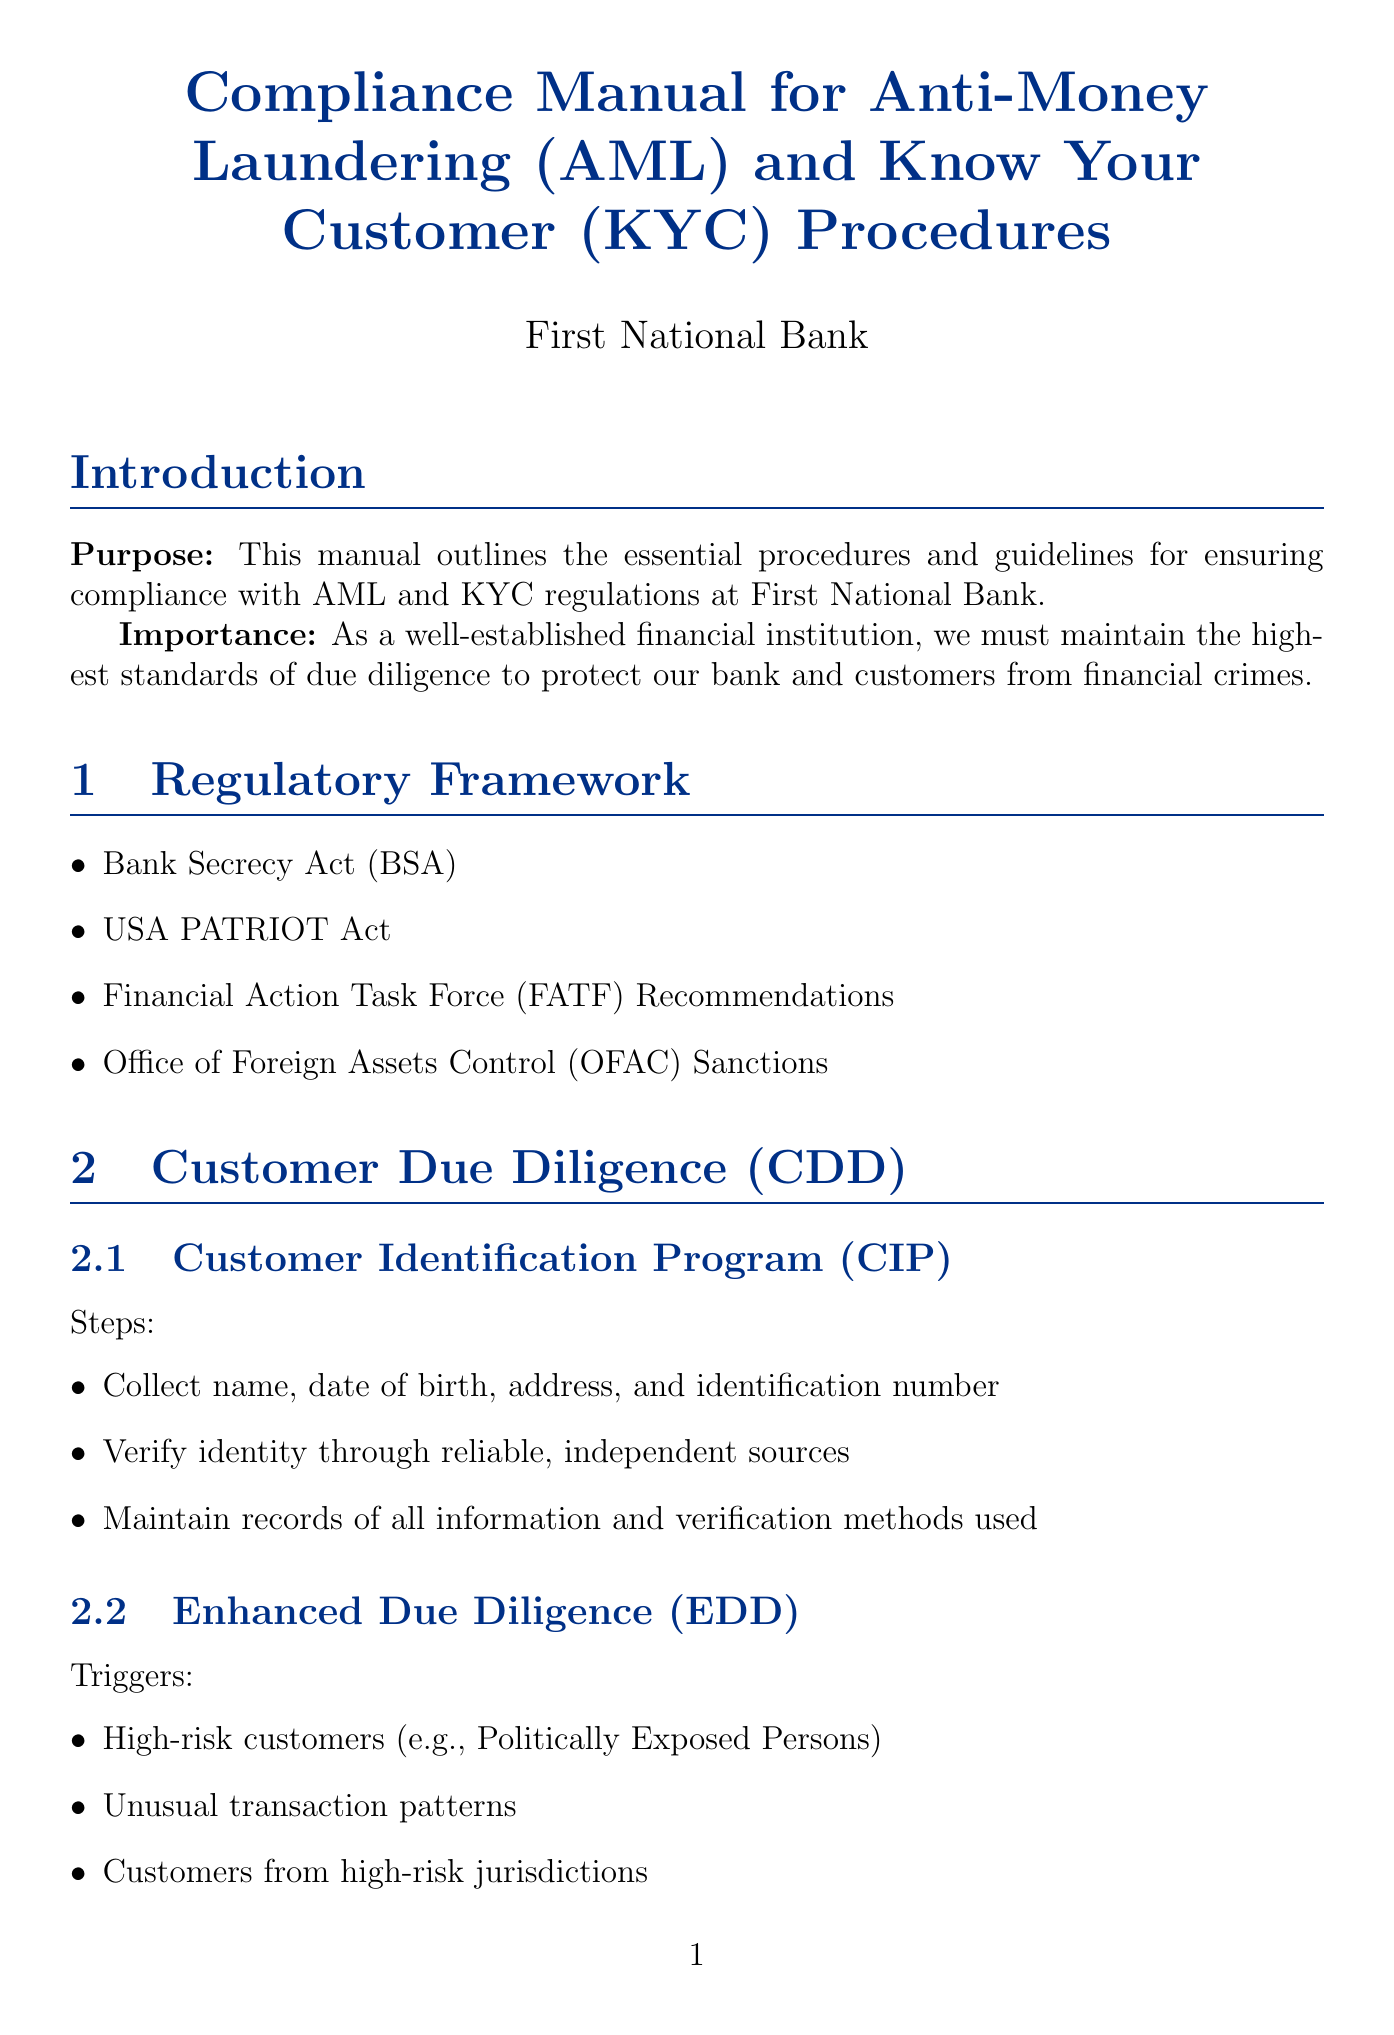What is the purpose of the manual? The purpose of the manual is to outline essential procedures and guidelines for ensuring compliance with AML and KYC regulations at First National Bank.
Answer: To outline essential procedures and guidelines for ensuring compliance with AML and KYC regulations at First National Bank Which act is part of the regulatory framework? The regulatory framework section lists several acts, including the Bank Secrecy Act.
Answer: Bank Secrecy Act How long must customer identification records be maintained after account closure? The Record Keeping section specifies that all customer identification records must be kept for 5 years after account closure.
Answer: 5 years What triggers Enhanced Due Diligence? The Enhanced Due Diligence subsection lists triggers that include high-risk customers, unusual transaction patterns, and customers from high-risk jurisdictions.
Answer: High-risk customers, unusual transaction patterns, customers from high-risk jurisdictions What is a consequence of non-compliance? The Risks of Non-Compliance section outlines several possible consequences including severe financial penalties.
Answer: Severe financial penalties How often is independent auditing conducted? The Independent Audit section states that an independent audit is conducted annually by a qualified third party.
Answer: Annually What kind of training is required for employees? The Training Program section indicates that annual AML/KYC training is provided for all employees.
Answer: Annual AML/KYC training How many days are allowed to investigate flagged transactions? The Suspicious Activity Reporting section allows for 30 days to investigate flagged transactions.
Answer: 30 days Which party conducts the independent audit? The Independent Audit section suggests that qualified third parties, such as KPMG or Deloitte, conduct the audit.
Answer: KPMG, Deloitte 